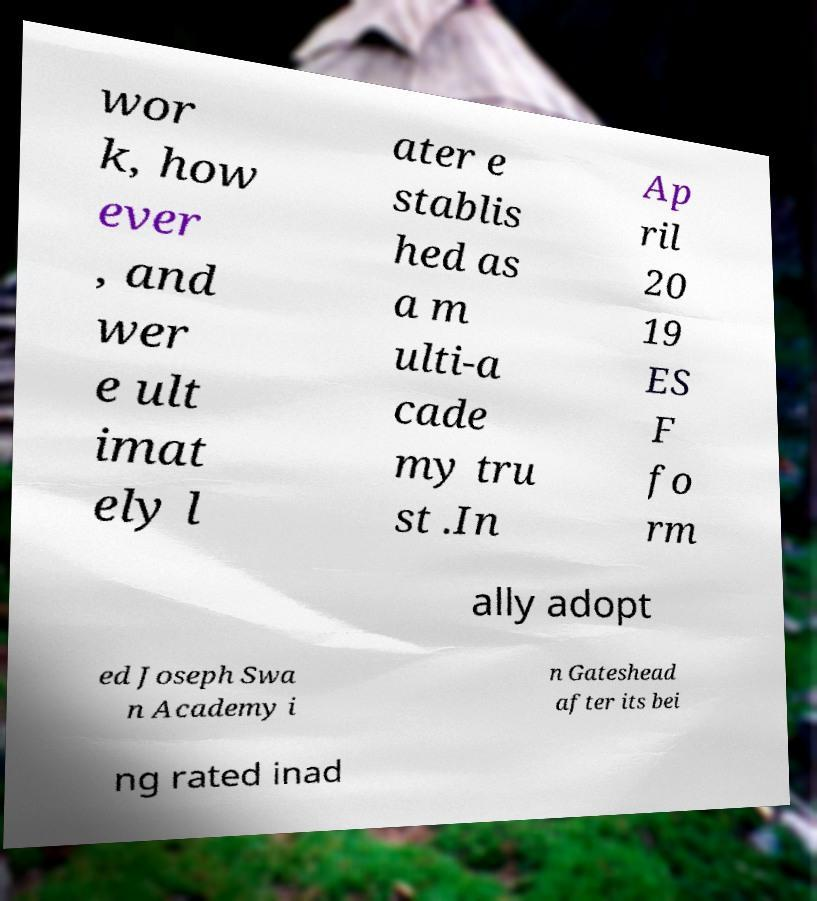For documentation purposes, I need the text within this image transcribed. Could you provide that? wor k, how ever , and wer e ult imat ely l ater e stablis hed as a m ulti-a cade my tru st .In Ap ril 20 19 ES F fo rm ally adopt ed Joseph Swa n Academy i n Gateshead after its bei ng rated inad 